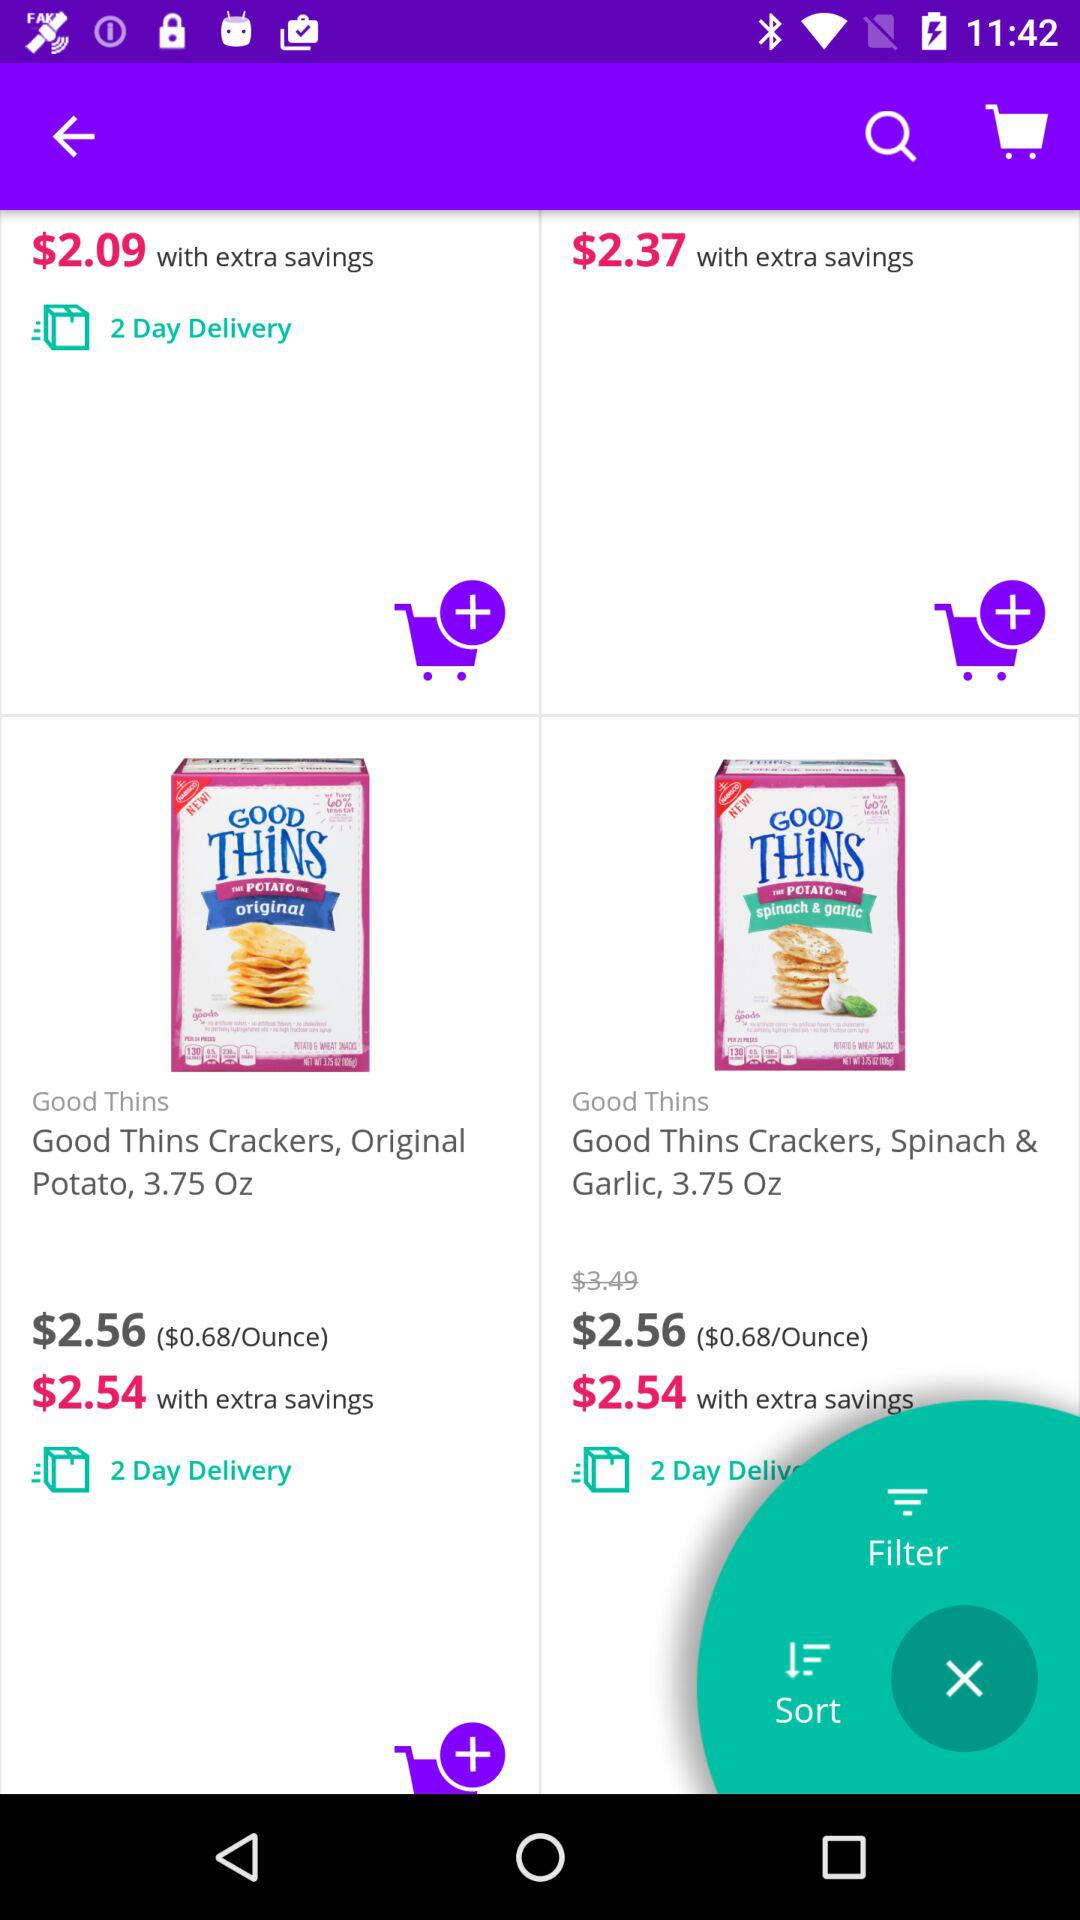What is the given duration for delivery? The duration for delivery is 2 days. 